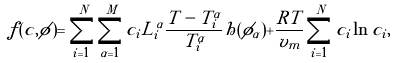Convert formula to latex. <formula><loc_0><loc_0><loc_500><loc_500>f ( c , \phi ) = \sum _ { i = 1 } ^ { N } \sum _ { \alpha = 1 } ^ { M } c _ { i } L _ { i } ^ { \alpha } \frac { T - T _ { i } ^ { \alpha } } { T _ { i } ^ { \alpha } } h ( \phi _ { \alpha } ) + \frac { R T } { v _ { m } } \sum _ { i = 1 } ^ { N } c _ { i } \ln c _ { i } ,</formula> 